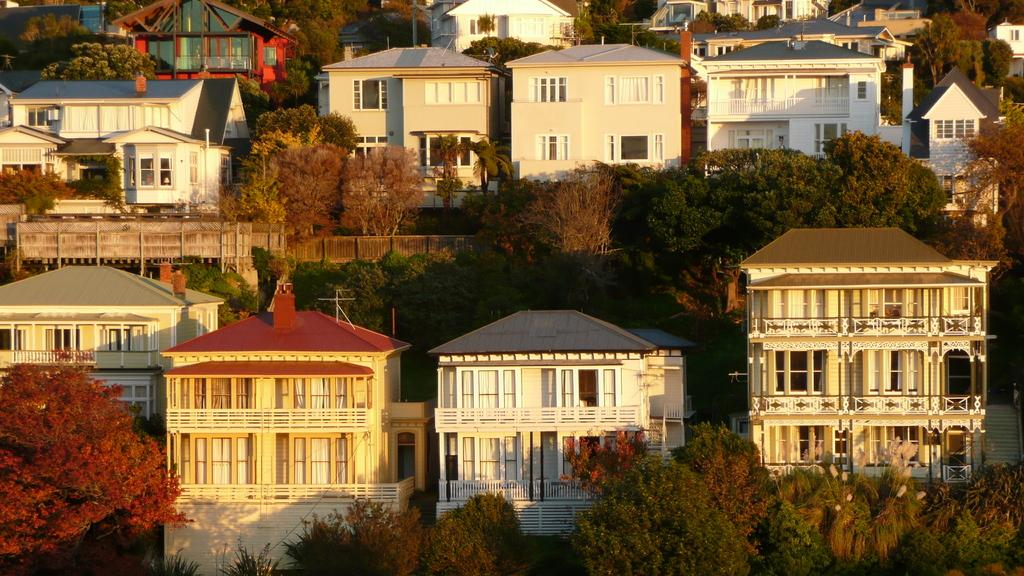What type of vegetation can be seen in the image? There are trees in the image. What color are the trees? The trees are green. What type of structures are present in the image? There are buildings in the image. What colors are the buildings? The buildings are in white, cream, and brown colors. Can you tell me how many bikes are parked near the church in the image? There is no church or bike present in the image; it only features trees and buildings. 